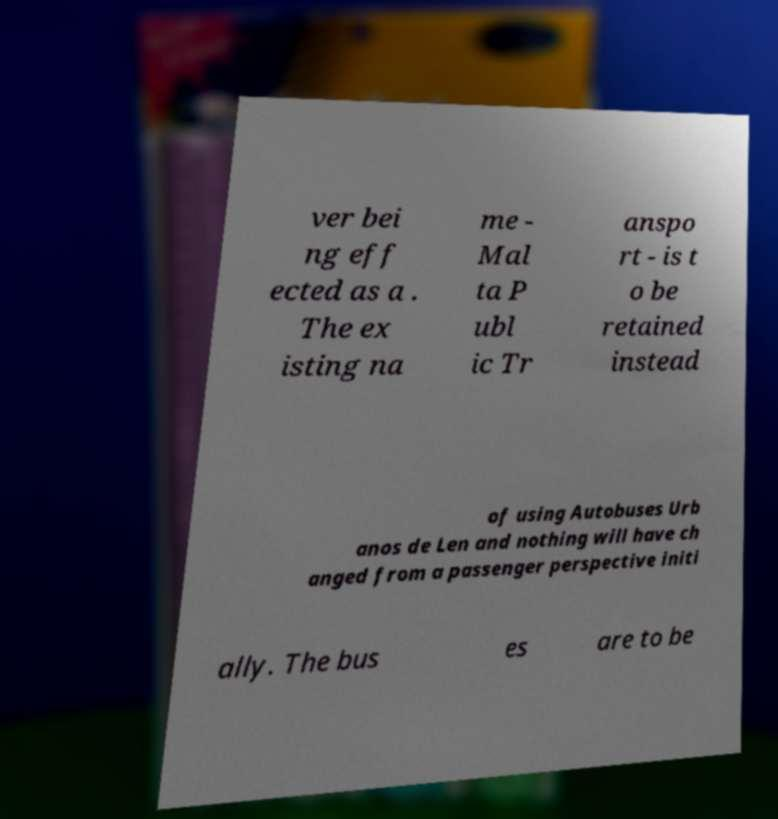What messages or text are displayed in this image? I need them in a readable, typed format. ver bei ng eff ected as a . The ex isting na me - Mal ta P ubl ic Tr anspo rt - is t o be retained instead of using Autobuses Urb anos de Len and nothing will have ch anged from a passenger perspective initi ally. The bus es are to be 